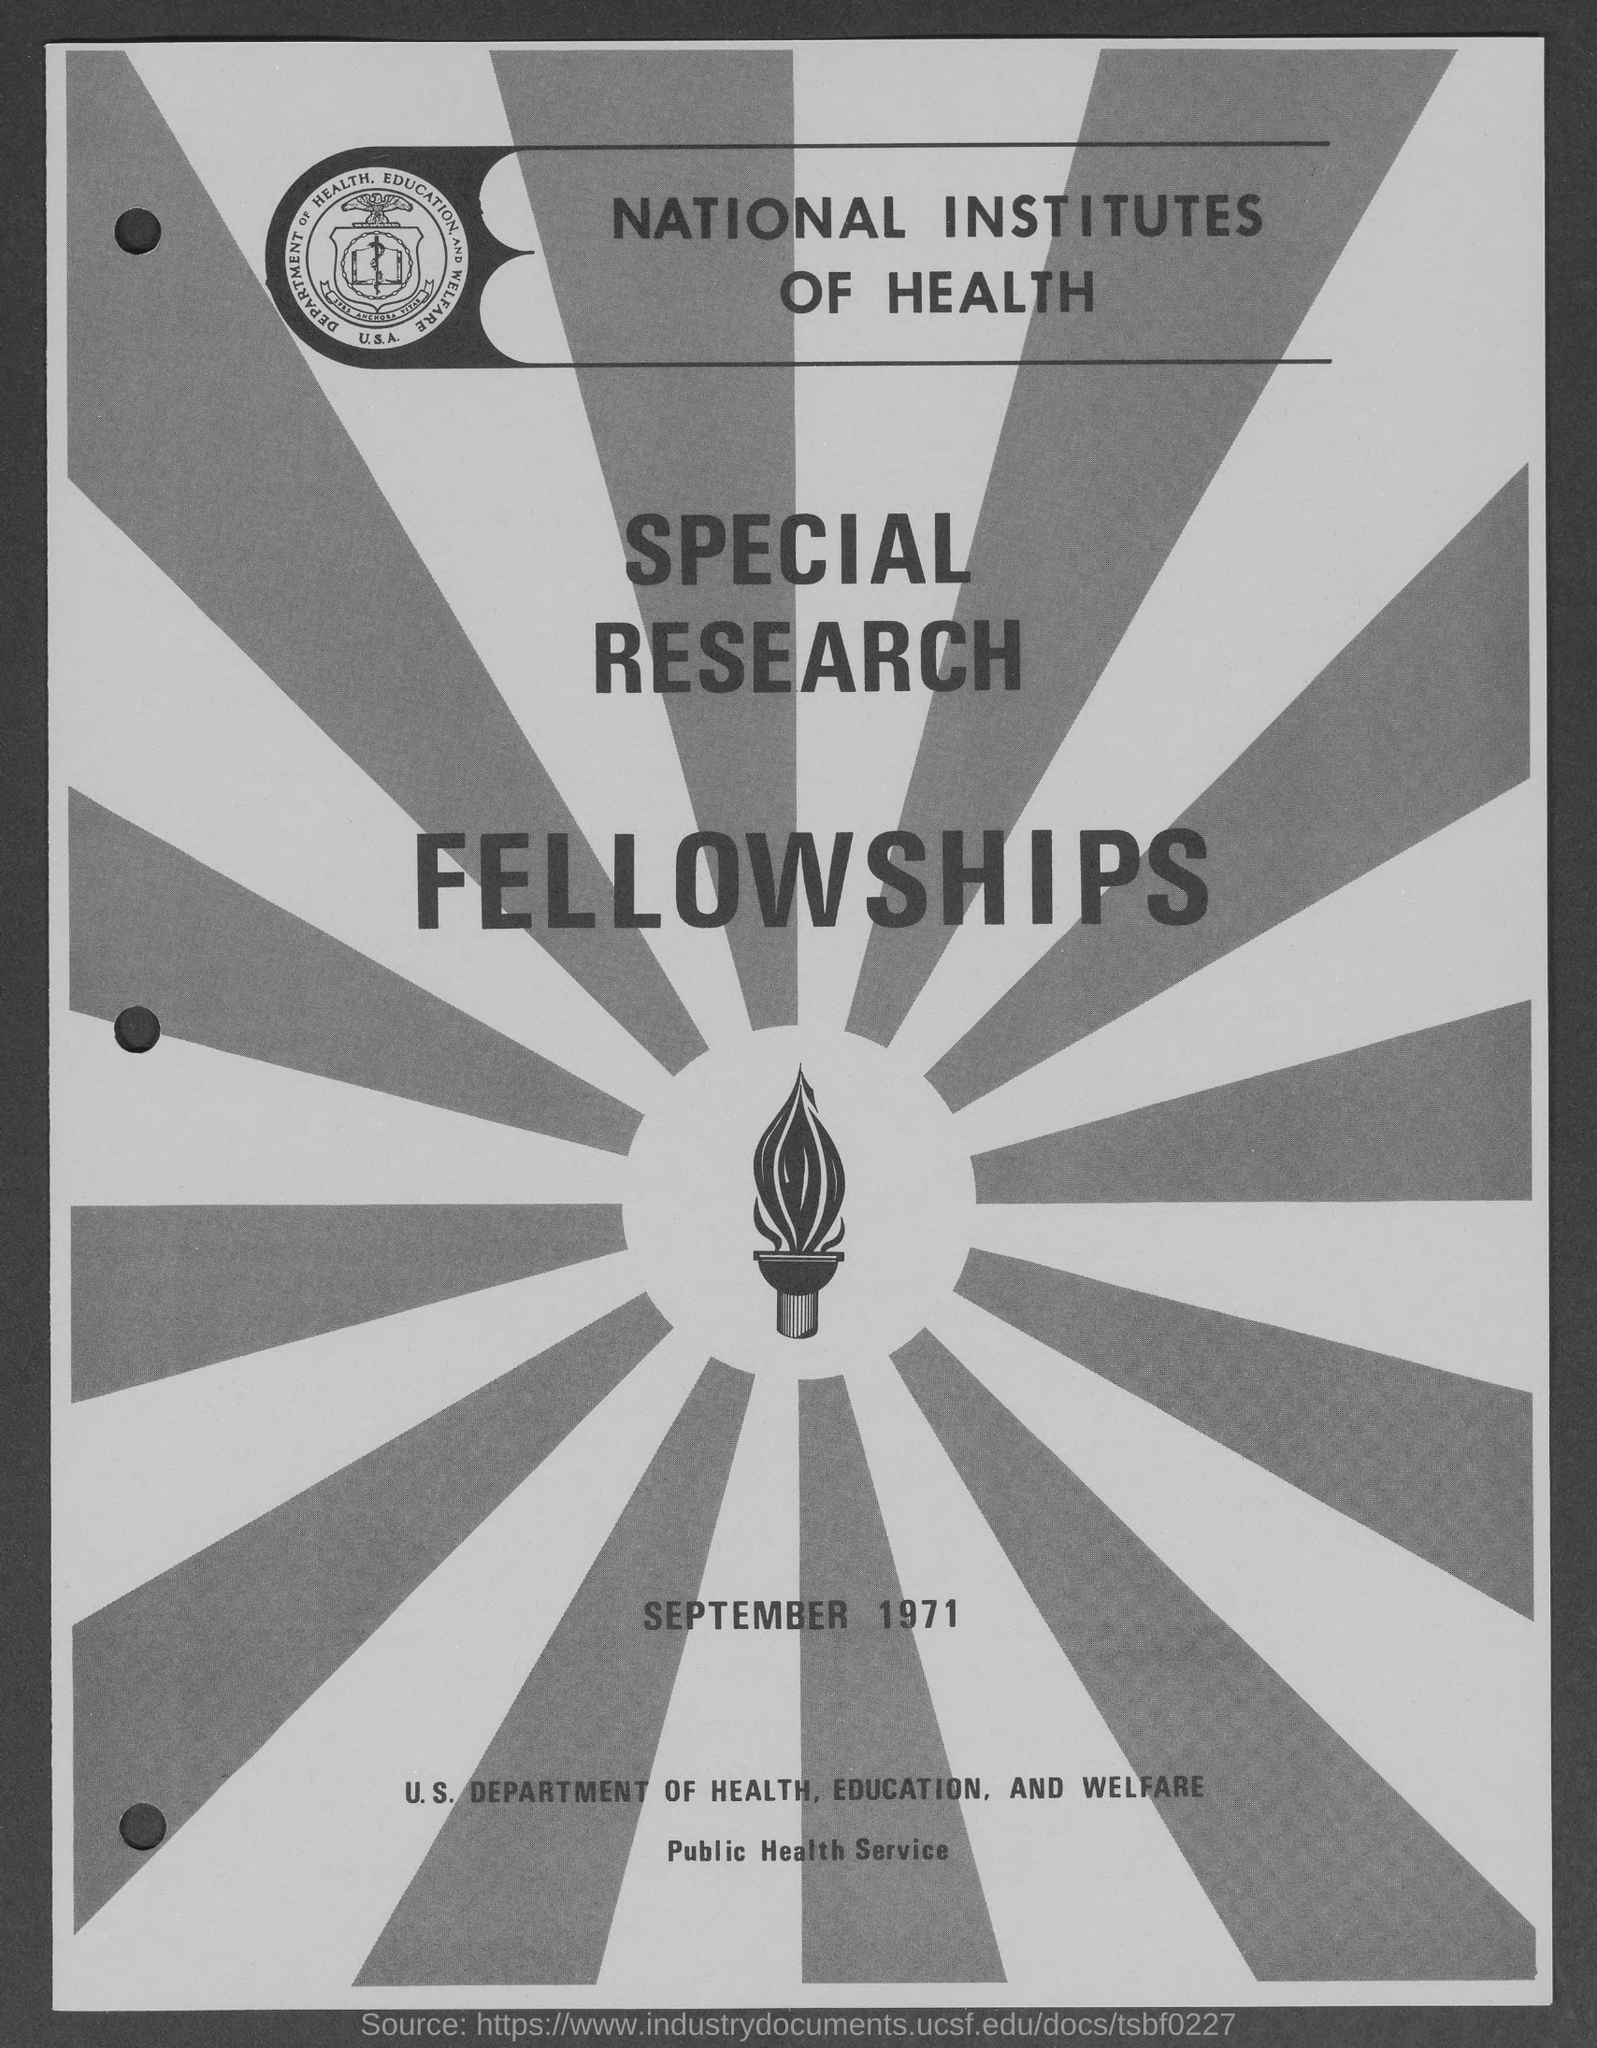Outline some significant characteristics in this image. The document contains the date of September 1971. The National Institutes of Health offer Special Research Fellowships. 